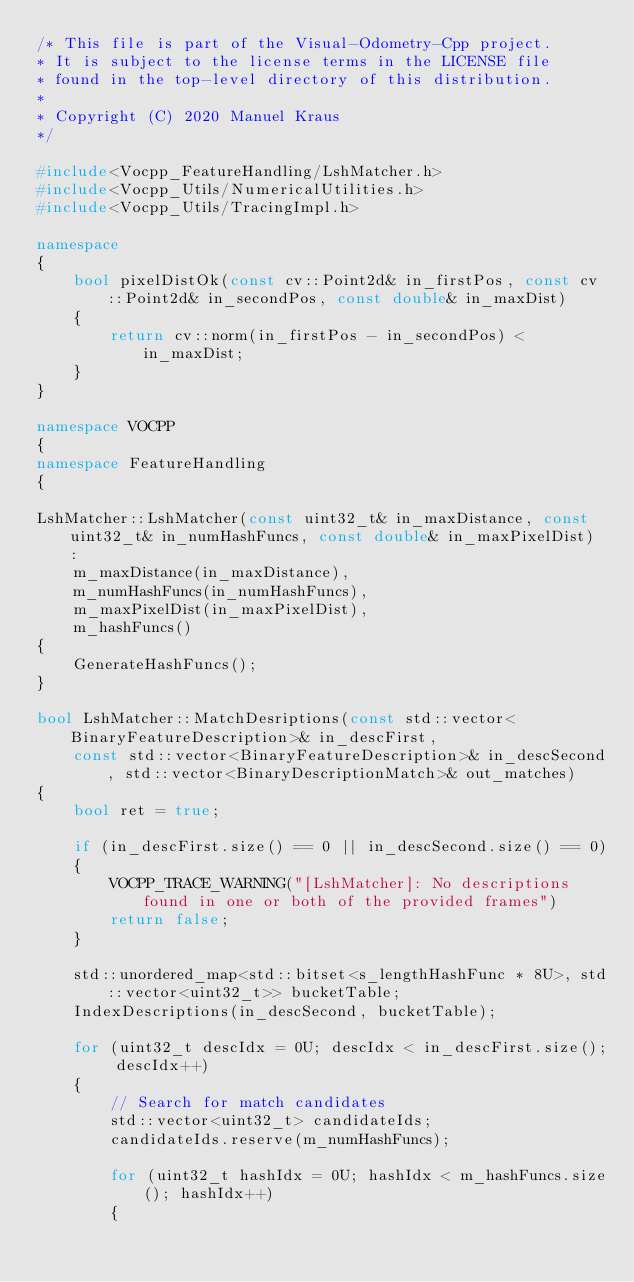Convert code to text. <code><loc_0><loc_0><loc_500><loc_500><_C++_>/* This file is part of the Visual-Odometry-Cpp project.
* It is subject to the license terms in the LICENSE file
* found in the top-level directory of this distribution.
*
* Copyright (C) 2020 Manuel Kraus
*/

#include<Vocpp_FeatureHandling/LshMatcher.h>
#include<Vocpp_Utils/NumericalUtilities.h>
#include<Vocpp_Utils/TracingImpl.h>

namespace
{
    bool pixelDistOk(const cv::Point2d& in_firstPos, const cv::Point2d& in_secondPos, const double& in_maxDist)
    {
        return cv::norm(in_firstPos - in_secondPos) < in_maxDist;
    }
}

namespace VOCPP
{
namespace FeatureHandling
{

LshMatcher::LshMatcher(const uint32_t& in_maxDistance, const uint32_t& in_numHashFuncs, const double& in_maxPixelDist) :
    m_maxDistance(in_maxDistance),
    m_numHashFuncs(in_numHashFuncs),
    m_maxPixelDist(in_maxPixelDist),
    m_hashFuncs()
{
    GenerateHashFuncs();
}

bool LshMatcher::MatchDesriptions(const std::vector<BinaryFeatureDescription>& in_descFirst,
    const std::vector<BinaryFeatureDescription>& in_descSecond, std::vector<BinaryDescriptionMatch>& out_matches)
{    
    bool ret = true;

    if (in_descFirst.size() == 0 || in_descSecond.size() == 0)
    {
        VOCPP_TRACE_WARNING("[LshMatcher]: No descriptions found in one or both of the provided frames")
        return false;
    }

    std::unordered_map<std::bitset<s_lengthHashFunc * 8U>, std::vector<uint32_t>> bucketTable;
    IndexDescriptions(in_descSecond, bucketTable);
    
    for (uint32_t descIdx = 0U; descIdx < in_descFirst.size(); descIdx++)
    {
        // Search for match candidates
        std::vector<uint32_t> candidateIds;
        candidateIds.reserve(m_numHashFuncs);
        
        for (uint32_t hashIdx = 0U; hashIdx < m_hashFuncs.size(); hashIdx++)
        {</code> 